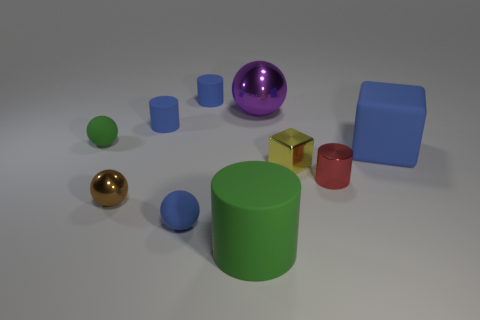Subtract 1 cylinders. How many cylinders are left? 3 Subtract all cylinders. How many objects are left? 6 Add 7 small blue matte objects. How many small blue matte objects exist? 10 Subtract 1 green cylinders. How many objects are left? 9 Subtract all tiny gray shiny cubes. Subtract all blocks. How many objects are left? 8 Add 6 purple metallic balls. How many purple metallic balls are left? 7 